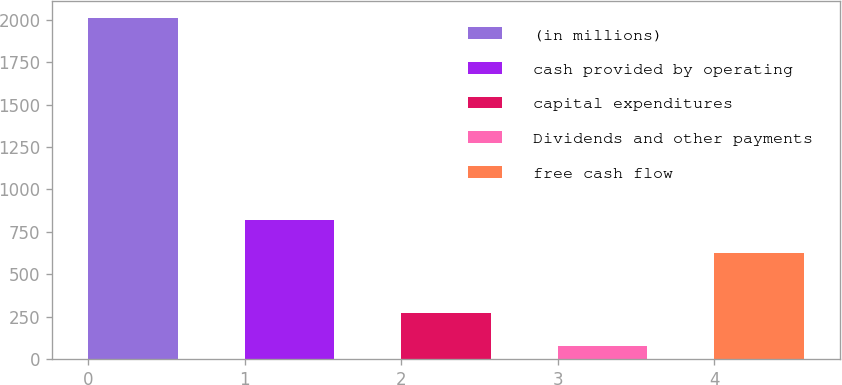Convert chart. <chart><loc_0><loc_0><loc_500><loc_500><bar_chart><fcel>(in millions)<fcel>cash provided by operating<fcel>capital expenditures<fcel>Dividends and other payments<fcel>free cash flow<nl><fcel>2013<fcel>817.8<fcel>268.8<fcel>75<fcel>624<nl></chart> 